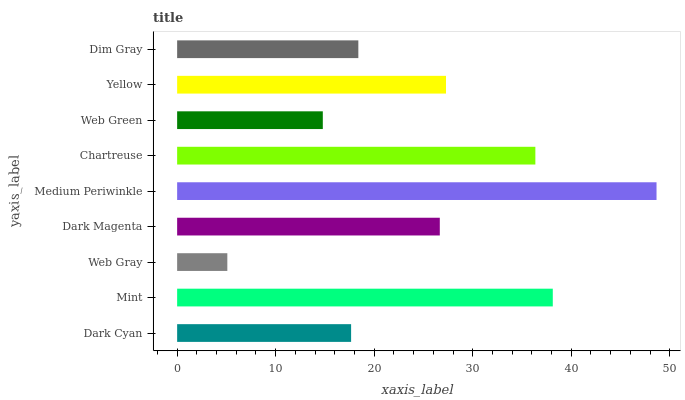Is Web Gray the minimum?
Answer yes or no. Yes. Is Medium Periwinkle the maximum?
Answer yes or no. Yes. Is Mint the minimum?
Answer yes or no. No. Is Mint the maximum?
Answer yes or no. No. Is Mint greater than Dark Cyan?
Answer yes or no. Yes. Is Dark Cyan less than Mint?
Answer yes or no. Yes. Is Dark Cyan greater than Mint?
Answer yes or no. No. Is Mint less than Dark Cyan?
Answer yes or no. No. Is Dark Magenta the high median?
Answer yes or no. Yes. Is Dark Magenta the low median?
Answer yes or no. Yes. Is Web Gray the high median?
Answer yes or no. No. Is Yellow the low median?
Answer yes or no. No. 